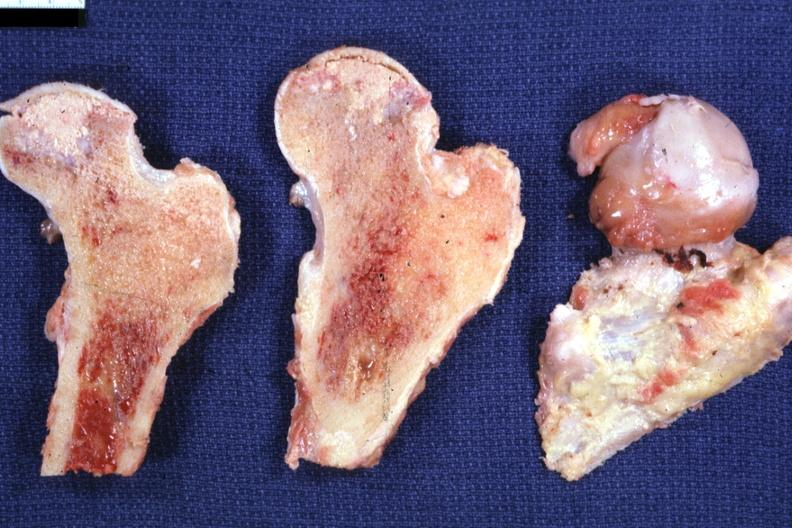what is present?
Answer the question using a single word or phrase. Joints 